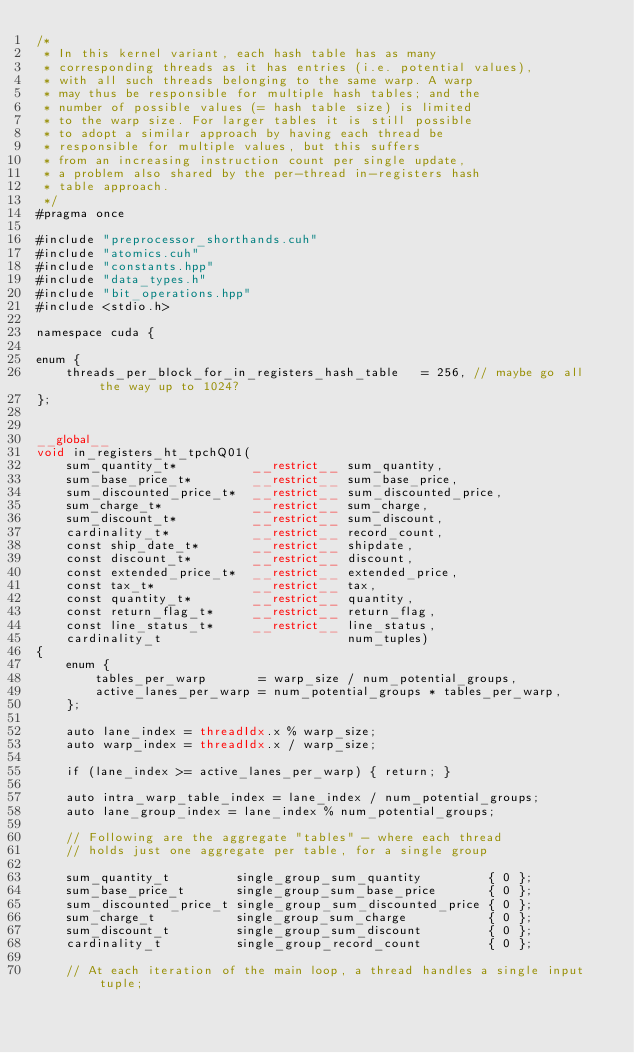<code> <loc_0><loc_0><loc_500><loc_500><_Cuda_>/*
 * In this kernel variant, each hash table has as many
 * corresponding threads as it has entries (i.e. potential values),
 * with all such threads belonging to the same warp. A warp
 * may thus be responsible for multiple hash tables; and the
 * number of possible values (= hash table size) is limited
 * to the warp size. For larger tables it is still possible
 * to adopt a similar approach by having each thread be
 * responsible for multiple values, but this suffers
 * from an increasing instruction count per single update,
 * a problem also shared by the per-thread in-registers hash
 * table approach.
 */
#pragma once

#include "preprocessor_shorthands.cuh"
#include "atomics.cuh"
#include "constants.hpp"
#include "data_types.h"
#include "bit_operations.hpp"
#include <stdio.h>

namespace cuda {

enum {
    threads_per_block_for_in_registers_hash_table   = 256, // maybe go all the way up to 1024?
};


__global__
void in_registers_ht_tpchQ01(
    sum_quantity_t*          __restrict__ sum_quantity,
    sum_base_price_t*        __restrict__ sum_base_price,
    sum_discounted_price_t*  __restrict__ sum_discounted_price,
    sum_charge_t*            __restrict__ sum_charge,
    sum_discount_t*          __restrict__ sum_discount,
    cardinality_t*           __restrict__ record_count,
    const ship_date_t*       __restrict__ shipdate,
    const discount_t*        __restrict__ discount,
    const extended_price_t*  __restrict__ extended_price,
    const tax_t*             __restrict__ tax,
    const quantity_t*        __restrict__ quantity,
    const return_flag_t*     __restrict__ return_flag,
    const line_status_t*     __restrict__ line_status,
    cardinality_t                         num_tuples)
{
    enum {
        tables_per_warp       = warp_size / num_potential_groups,
        active_lanes_per_warp = num_potential_groups * tables_per_warp,
    };

    auto lane_index = threadIdx.x % warp_size;
    auto warp_index = threadIdx.x / warp_size;

    if (lane_index >= active_lanes_per_warp) { return; }

    auto intra_warp_table_index = lane_index / num_potential_groups;
    auto lane_group_index = lane_index % num_potential_groups;

    // Following are the aggregate "tables" - where each thread
    // holds just one aggregate per table, for a single group

    sum_quantity_t         single_group_sum_quantity         { 0 };
    sum_base_price_t       single_group_sum_base_price       { 0 };
    sum_discounted_price_t single_group_sum_discounted_price { 0 };
    sum_charge_t           single_group_sum_charge           { 0 };
    sum_discount_t         single_group_sum_discount         { 0 };
    cardinality_t          single_group_record_count         { 0 };

    // At each iteration of the main loop, a thread handles a single input tuple;</code> 